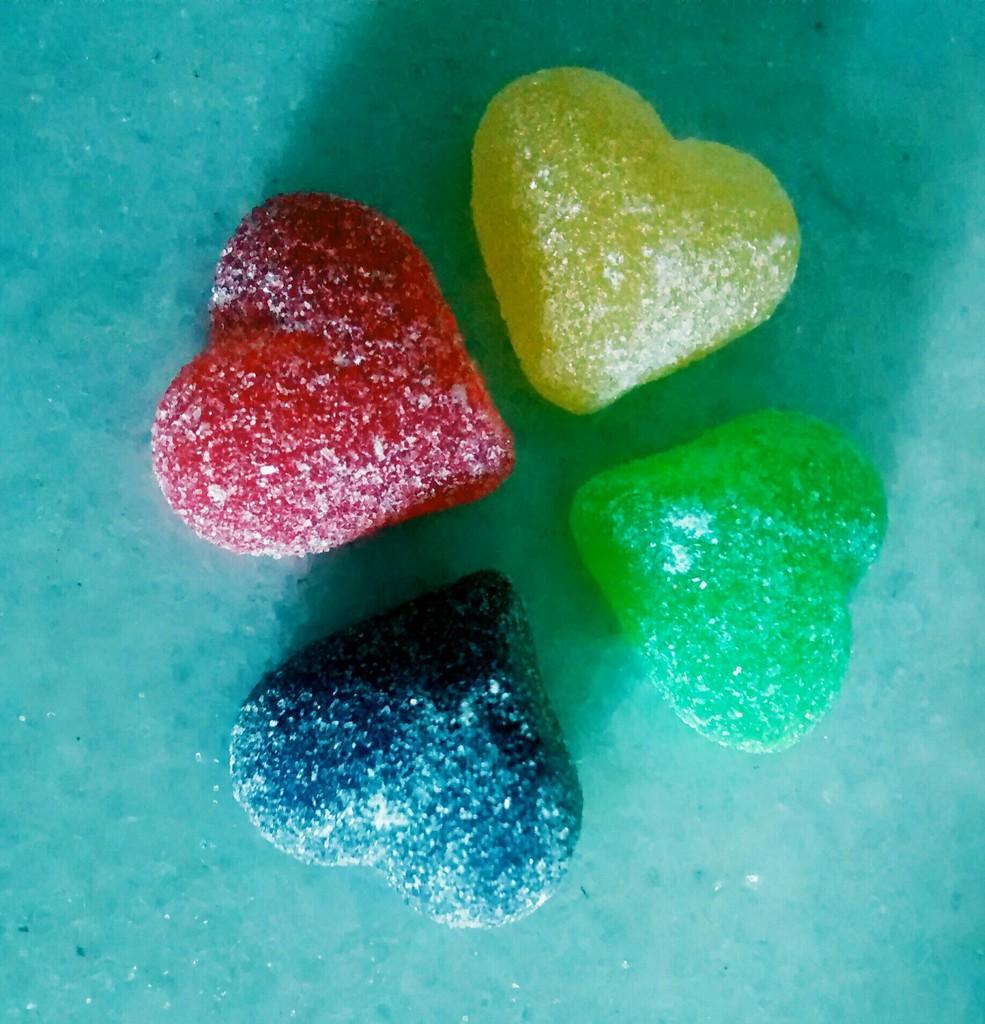Could you give a brief overview of what you see in this image? In this image, we can see colorful candies on the blue surface. 